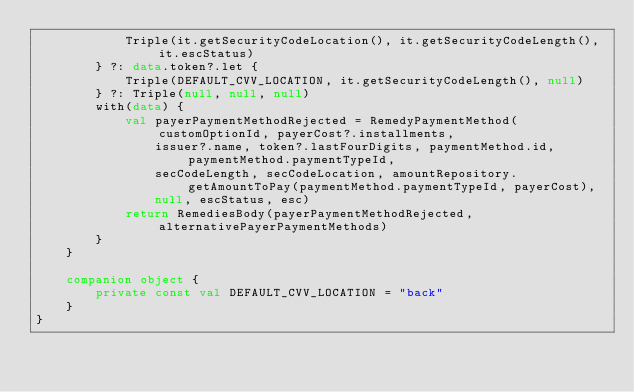Convert code to text. <code><loc_0><loc_0><loc_500><loc_500><_Kotlin_>            Triple(it.getSecurityCodeLocation(), it.getSecurityCodeLength(), it.escStatus)
        } ?: data.token?.let {
            Triple(DEFAULT_CVV_LOCATION, it.getSecurityCodeLength(), null)
        } ?: Triple(null, null, null)
        with(data) {
            val payerPaymentMethodRejected = RemedyPaymentMethod(customOptionId, payerCost?.installments,
                issuer?.name, token?.lastFourDigits, paymentMethod.id, paymentMethod.paymentTypeId,
                secCodeLength, secCodeLocation, amountRepository.getAmountToPay(paymentMethod.paymentTypeId, payerCost),
                null, escStatus, esc)
            return RemediesBody(payerPaymentMethodRejected, alternativePayerPaymentMethods)
        }
    }

    companion object {
        private const val DEFAULT_CVV_LOCATION = "back"
    }
}</code> 